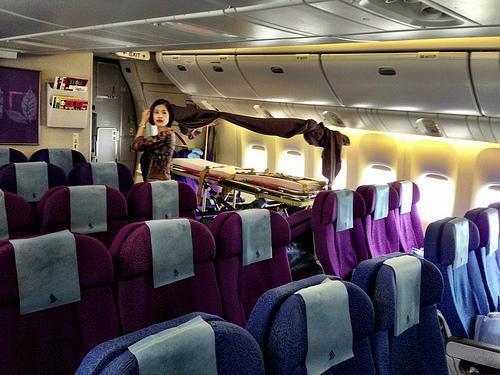How many people are pictured?
Give a very brief answer. 1. 